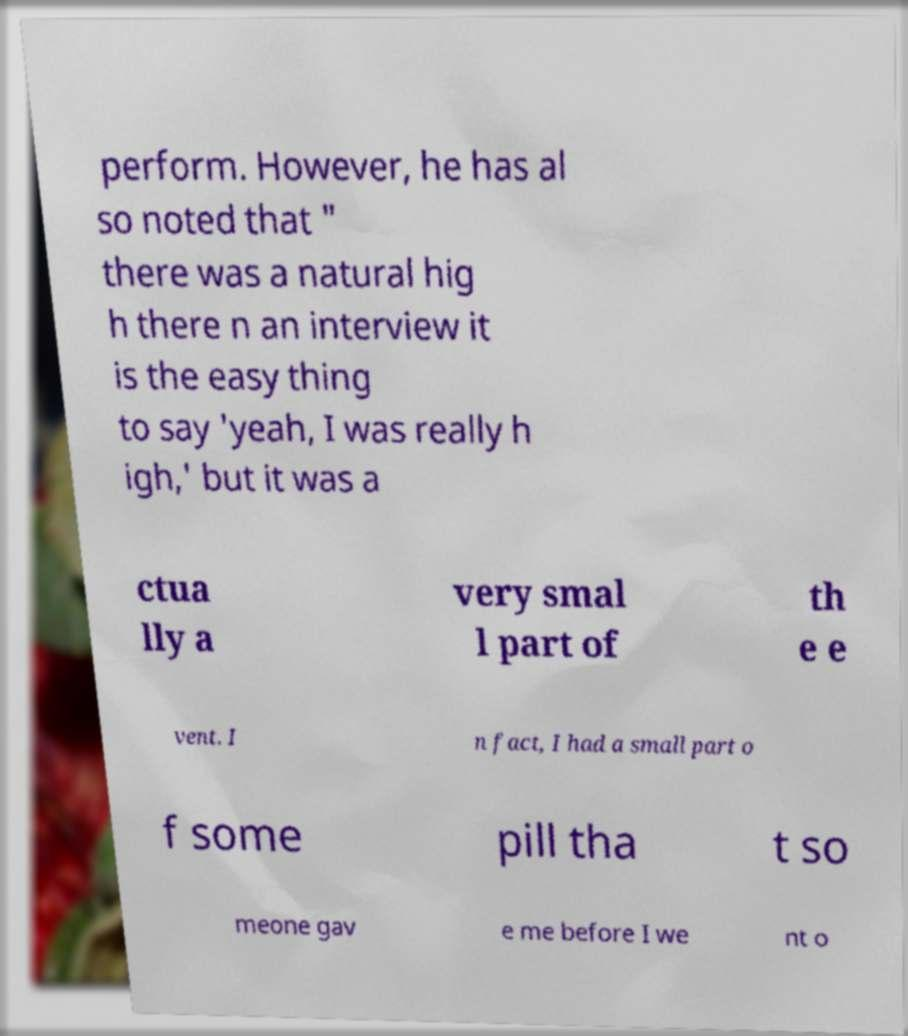Could you assist in decoding the text presented in this image and type it out clearly? perform. However, he has al so noted that " there was a natural hig h there n an interview it is the easy thing to say 'yeah, I was really h igh,' but it was a ctua lly a very smal l part of th e e vent. I n fact, I had a small part o f some pill tha t so meone gav e me before I we nt o 